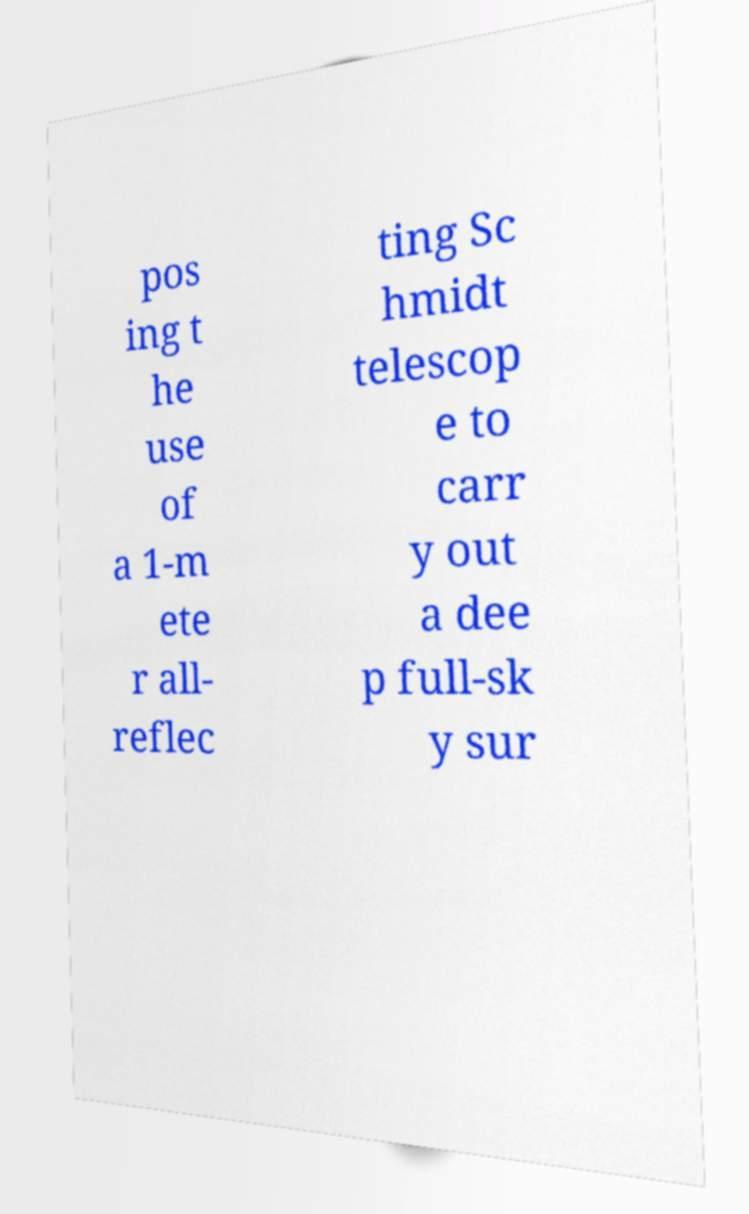Please identify and transcribe the text found in this image. pos ing t he use of a 1-m ete r all- reflec ting Sc hmidt telescop e to carr y out a dee p full-sk y sur 